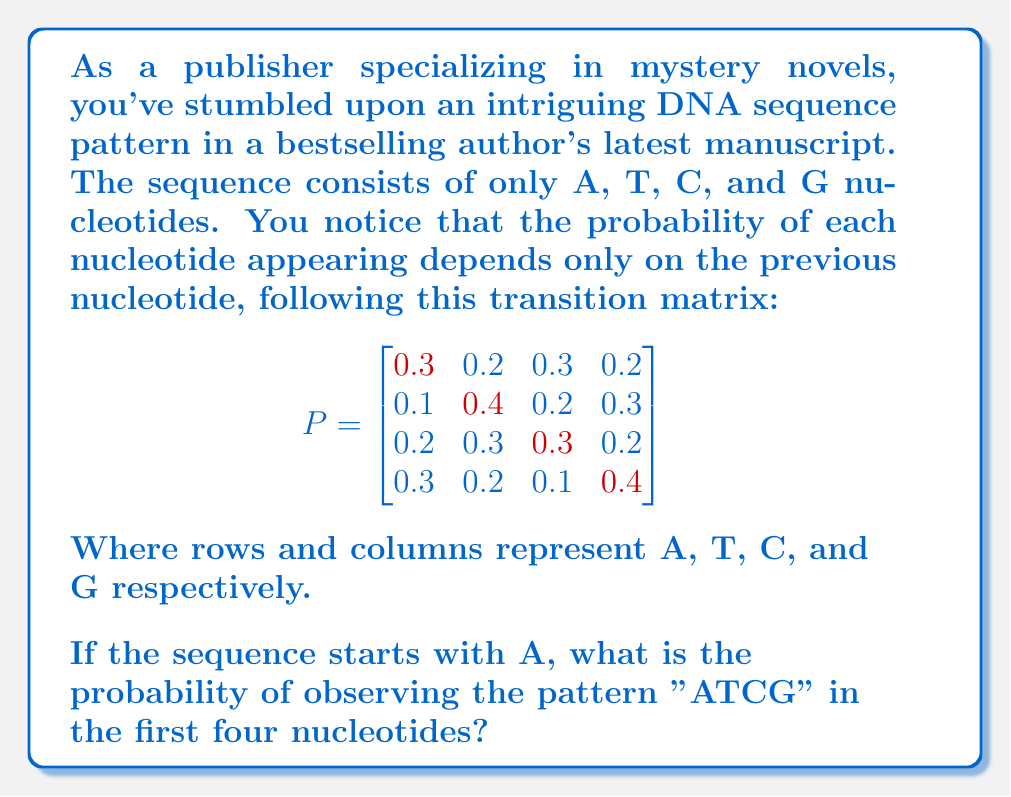Provide a solution to this math problem. Let's approach this step-by-step using Markov chains:

1) We need to calculate $P(ATCG|A)$, which can be broken down as:
   $P(ATCG|A) = P(T|A) \cdot P(C|T) \cdot P(G|C)$

2) From the transition matrix:
   $P(T|A) = 0.2$ (2nd column, 1st row)
   $P(C|T) = 0.2$ (3rd column, 2nd row)
   $P(G|C) = 0.2$ (4th column, 3rd row)

3) Multiply these probabilities:
   $P(ATCG|A) = 0.2 \cdot 0.2 \cdot 0.2 = 0.008$

4) Therefore, the probability of observing "ATCG" starting from A is 0.008 or 0.8%.
Answer: 0.008 